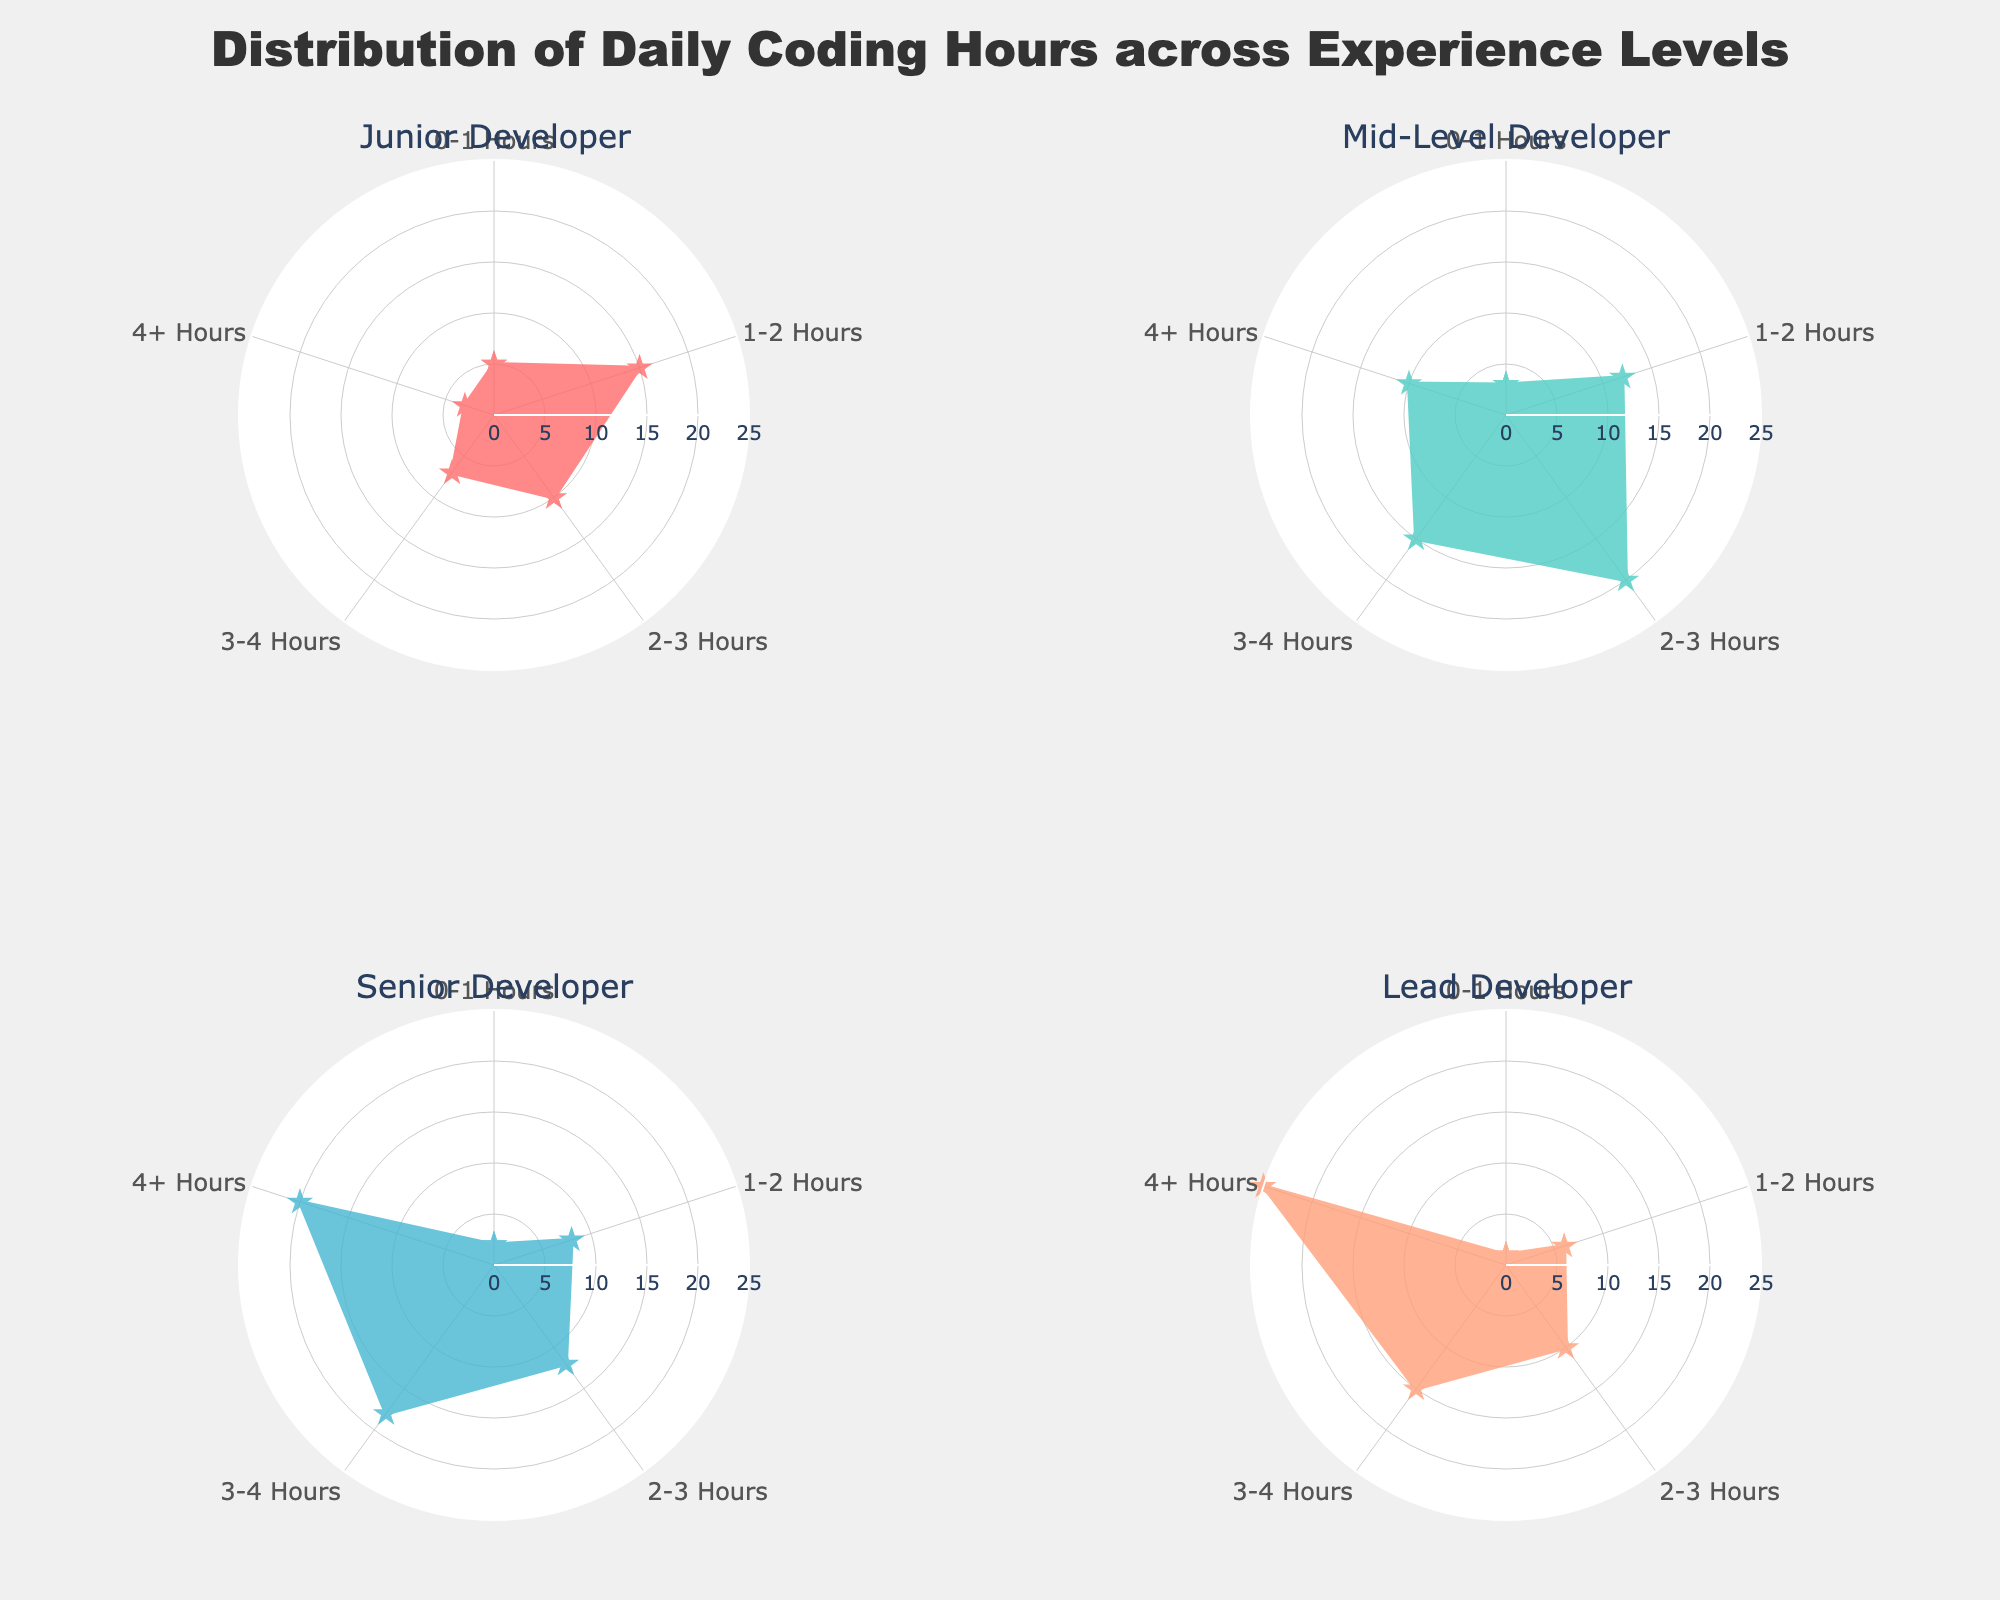What is the title of the figure? The title of the figure is located at the top and it is a textual element that describes the chart. In this case, the title reads "Distribution of Daily Coding Hours across Experience Levels".
Answer: Distribution of Daily Coding Hours across Experience Levels Which Experience Level has the highest proportion of individuals coding for 4+ hours per day? By examining the figure, the segment corresponding to "4+ Hours" needs to be observed for each experience level. The Lead Developer experience level has the largest area in this segment, indicating it has the highest proportion.
Answer: Lead Developer For Junior Developers, what is the pattern of coding hours from 0-1 up to 4+ hours? The pattern can be seen by following the segments clockwise. For Junior Developers, the coding hours increase sharply from 0-1 Hours to 1-2 Hours, then slightly drop from 2-3 Hours to 4+ Hours.
Answer: Increases sharply, then drops slightly Compare the coding hours distribution between Mid-Level Developers and Senior Developers. Who spends more time coding overall? To determine who spends more time coding overall, we need to assess the areas of the segments representing longer durations. Senior Developers have larger areas in the greater than 2 hours categories compared to Mid-Level Developers.
Answer: Senior Developers What are the radial axis ranges displayed in the figure? By looking at the radial axis lines extending outward from the center, we can see they are labeled to indicate a range. The radial axis ranges from 0 to the highest count, which is derived from the data, here it is 25.
Answer: 0 to 25 What color is used for the Junior Developer experience level in the rose chart? The color used for each experience level's segments is distinct. By examining the corresponding plot, we observe that Junior Developer is colored in a shade of red.
Answer: Red How does the coding hours distribution for Senior Developers compare against Lead Developers for the 2-3 hours segment? Observing the specific segment representing 2-3 hours for both Senior Developers and Lead Developers, we can see that the area for Senior Developers is larger than that of Lead Developers.
Answer: Senior Developers have a larger segment area Which experience level has the smallest proportion of people coding between 1-2 hours? By examining the 1-2 hours segments in each subplot, the smallest segment area belongs to Lead Developers.
Answer: Lead Developer 